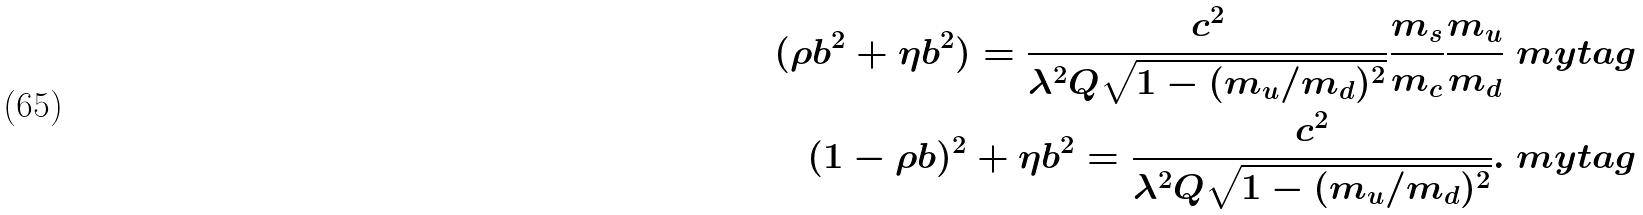Convert formula to latex. <formula><loc_0><loc_0><loc_500><loc_500>( \rho b ^ { 2 } + \eta b ^ { 2 } ) = \frac { c ^ { 2 } } { \lambda ^ { 2 } Q \sqrt { 1 - ( m _ { u } / m _ { d } ) ^ { 2 } } } \frac { m _ { s } } { m _ { c } } \frac { m _ { u } } { m _ { d } } \ m y t a g \\ ( 1 - \rho b ) ^ { 2 } + \eta b ^ { 2 } = \frac { c ^ { 2 } } { \lambda ^ { 2 } Q \sqrt { 1 - ( m _ { u } / m _ { d } ) ^ { 2 } } } . \ m y t a g</formula> 